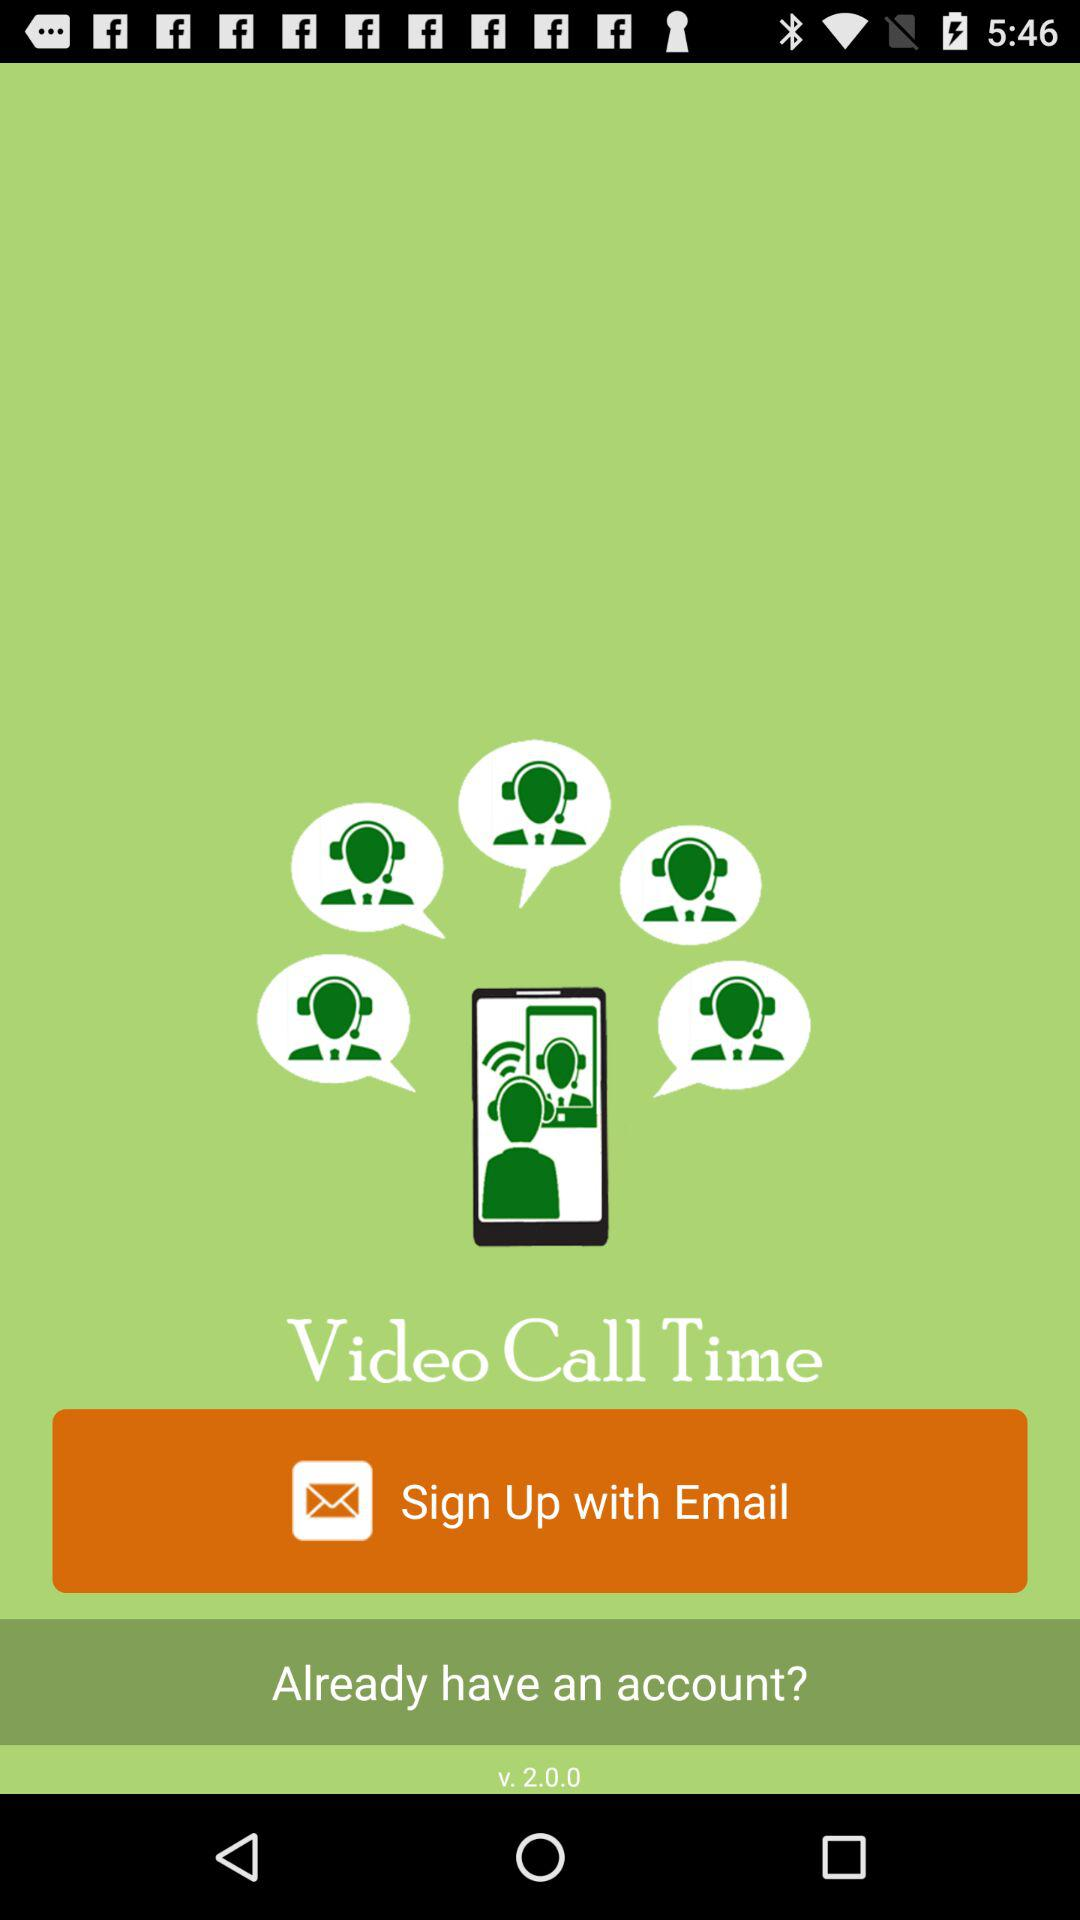What account can we sign up with? You can sign up with an "Email" account. 